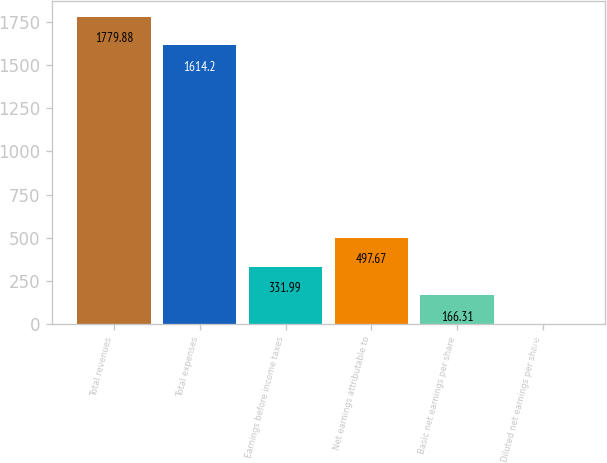Convert chart to OTSL. <chart><loc_0><loc_0><loc_500><loc_500><bar_chart><fcel>Total revenues<fcel>Total expenses<fcel>Earnings before income taxes<fcel>Net earnings attributable to<fcel>Basic net earnings per share<fcel>Diluted net earnings per share<nl><fcel>1779.88<fcel>1614.2<fcel>331.99<fcel>497.67<fcel>166.31<fcel>0.63<nl></chart> 